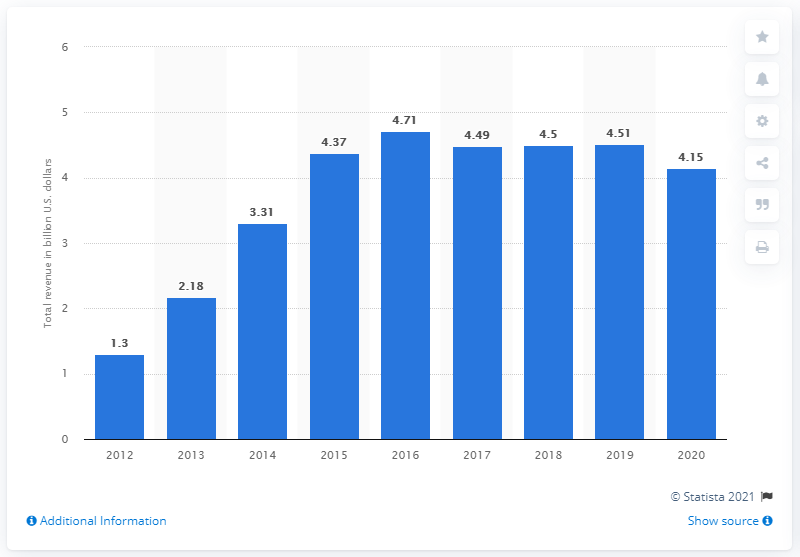Point out several critical features in this image. In the year 2020, the total revenue of Michael Kors was 4.15 billion US dollars. 